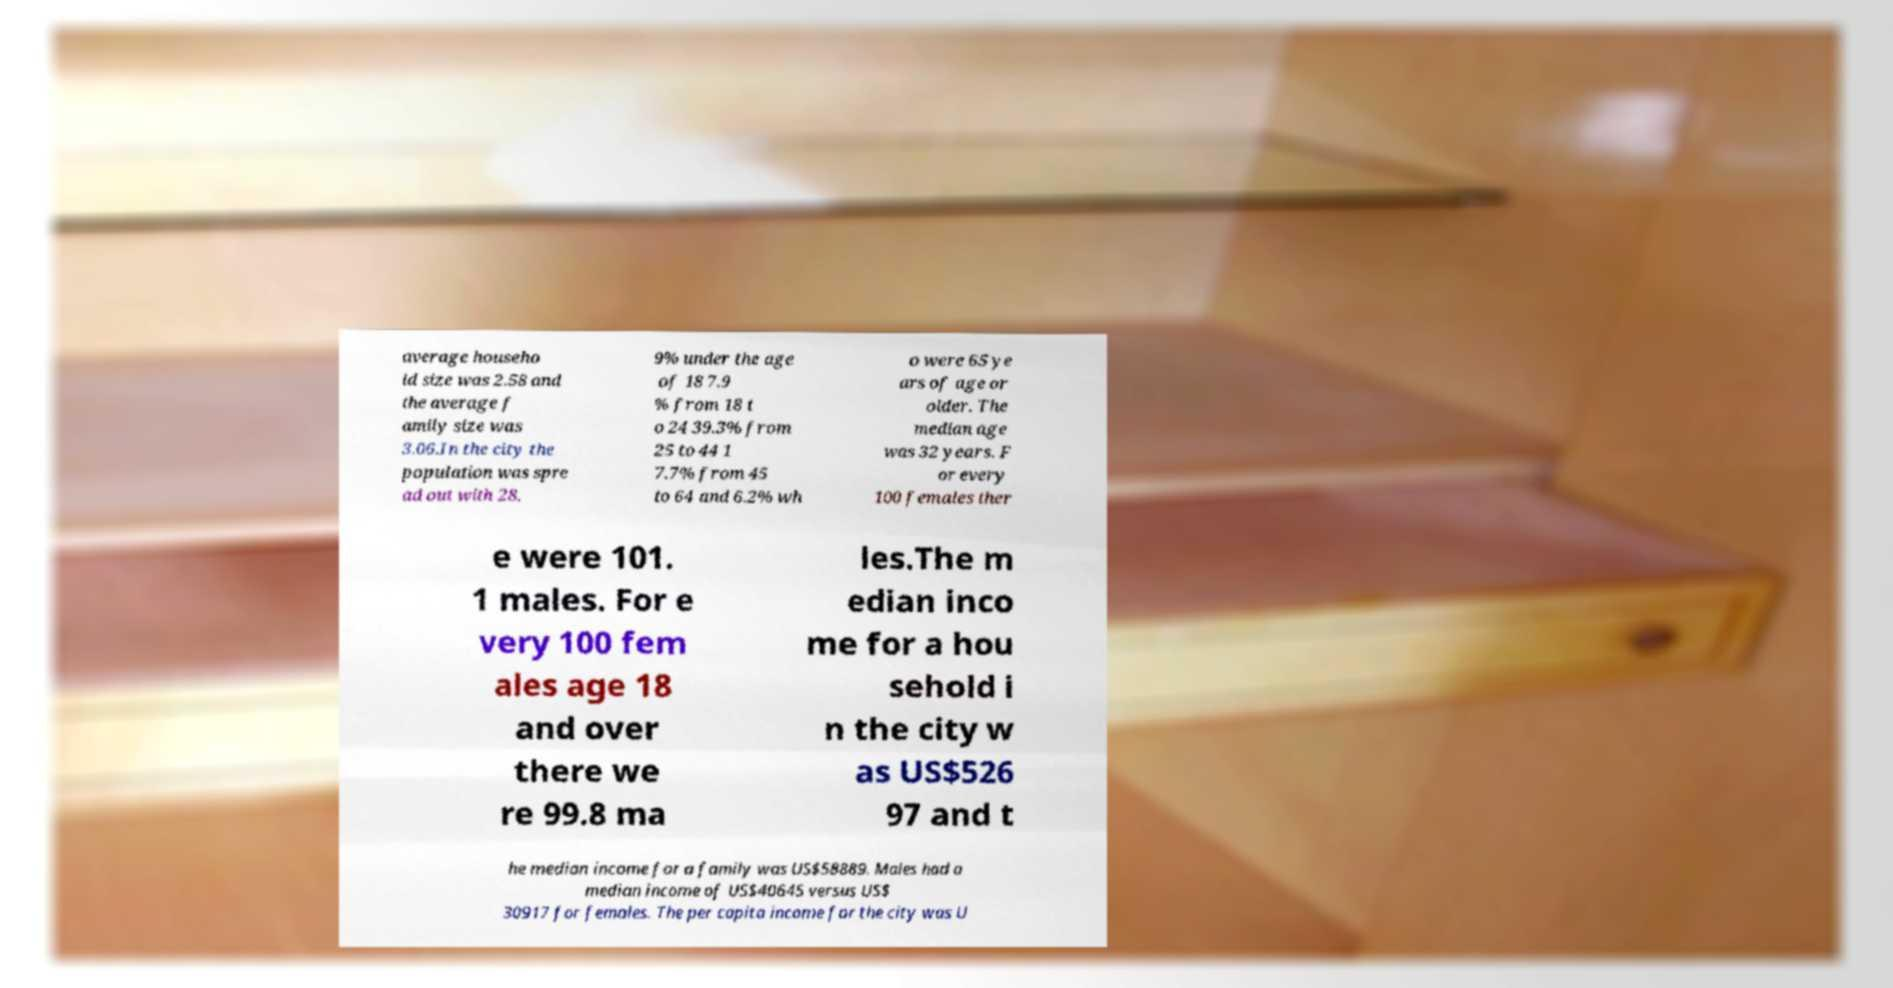Please read and relay the text visible in this image. What does it say? average househo ld size was 2.58 and the average f amily size was 3.06.In the city the population was spre ad out with 28. 9% under the age of 18 7.9 % from 18 t o 24 39.3% from 25 to 44 1 7.7% from 45 to 64 and 6.2% wh o were 65 ye ars of age or older. The median age was 32 years. F or every 100 females ther e were 101. 1 males. For e very 100 fem ales age 18 and over there we re 99.8 ma les.The m edian inco me for a hou sehold i n the city w as US$526 97 and t he median income for a family was US$58889. Males had a median income of US$40645 versus US$ 30917 for females. The per capita income for the city was U 